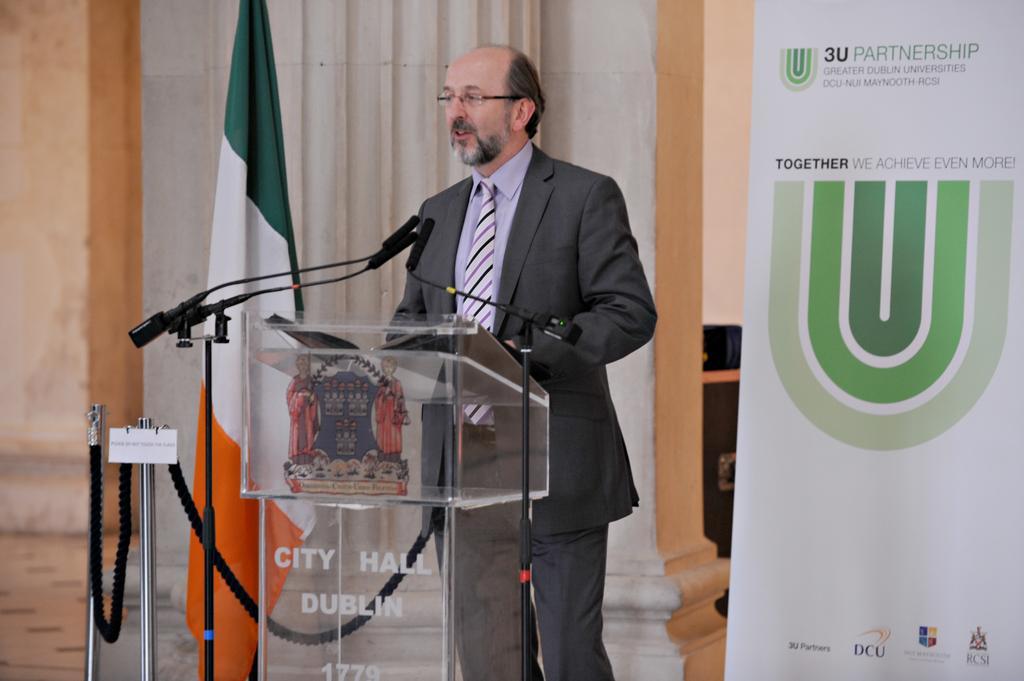Please provide a concise description of this image. In this image there is a person standing in front of the dais. On top of the days there are mike's. Beside him there is a flag. On the right side of the image there is a banner. In the center of the image there is a pillar. On the left side of the image there is a wall. At the bottom of the image there is a floor. 